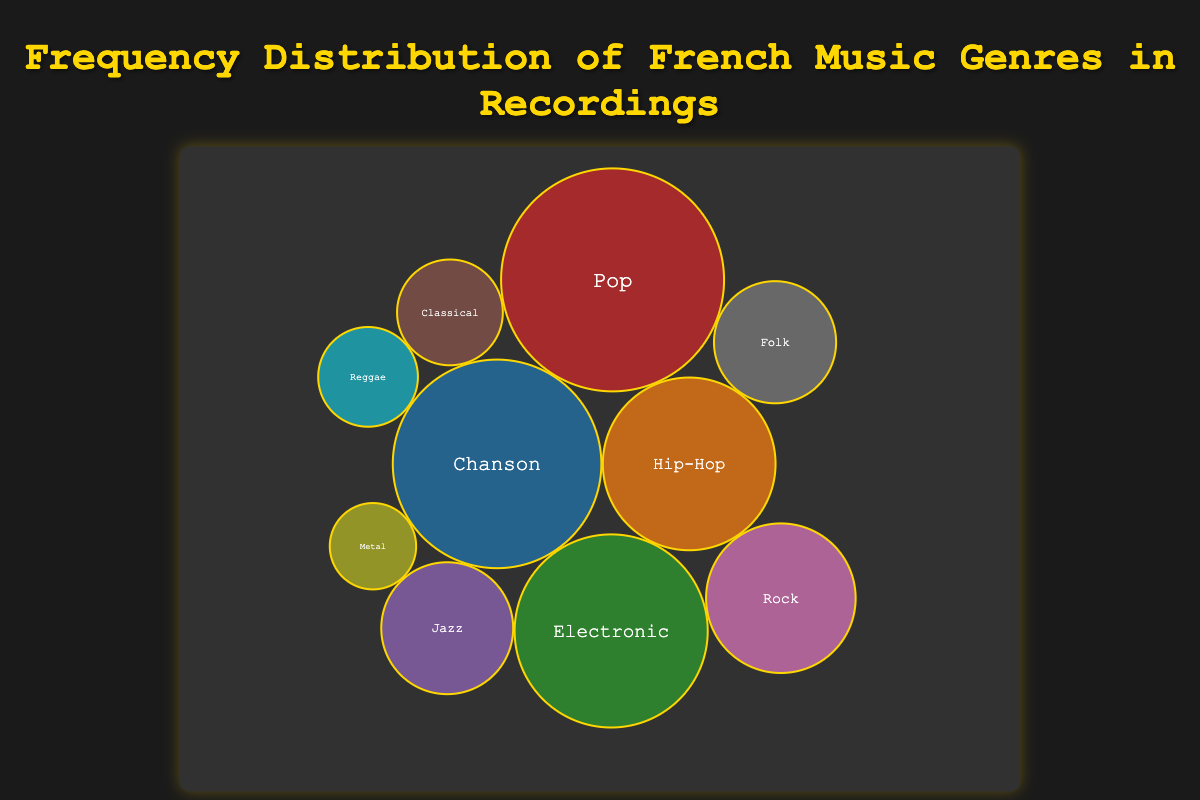What's the title of the bubble chart? The title is displayed at the top of the chart in large, bold text. It says "Frequency Distribution of French Music Genres in Recordings".
Answer: Frequency Distribution of French Music Genres in Recordings How many genres are displayed in the bubble chart? To find this, count the number of distinct bubbles in the chart. Each bubble represents a genre.
Answer: 10 Which genre has the highest frequency and what is its popularity? Look for the largest bubble in the chart and hover over it to read the information displayed. The largest bubble represents the genre with the highest frequency.
Answer: Pop, 95 Which genre has the lowest frequency and what is its popularity? Find the smallest bubble in the chart and hover over it to get the details. The smallest bubble corresponds to the genre with the lowest frequency.
Answer: Metal, 55 What is the combined frequency of Chanson and Electronic music? Identify the bubbles for Chanson and Electronic, then sum their frequencies. Chanson has a frequency of 175, and Electronic has 150. Adding these, \(175 + 150 = 325\).
Answer: 325 Which has a higher frequency, Jazz or Folk, and by how much? Compare the sizes of the bubbles for Jazz and Folk, hovering over each for details. Jazz has a frequency of 70, and Folk has 60. The difference is \(70 - 60 = 10\).
Answer: Jazz, 10 List all the genres that have a popularity of 70 or above. Check each bubble's hovered information for popularity values at or above 70. The genres that meet this criterion are Chanson, Hip-Hop, Electronic, Pop, Rock, and Folk.
Answer: Chanson, Hip-Hop, Electronic, Pop, Rock, Folk Which genre has a higher popularity, Rock or Reggae? Compare the popularity values displayed in the hovered information for Rock and Reggae. Rock has a popularity of 74, while Reggae has 60.
Answer: Rock What's the average popularity of the genres displayed? Sum the popularity values of all genres and divide by the number of genres. The total popularity is \(85 + 90 + 79 + 95 + 65 + 50 + 74 + 66 + 55 + 60 = 719\). Divide by 10, \(719 / 10 = 71.9\).
Answer: 71.9 